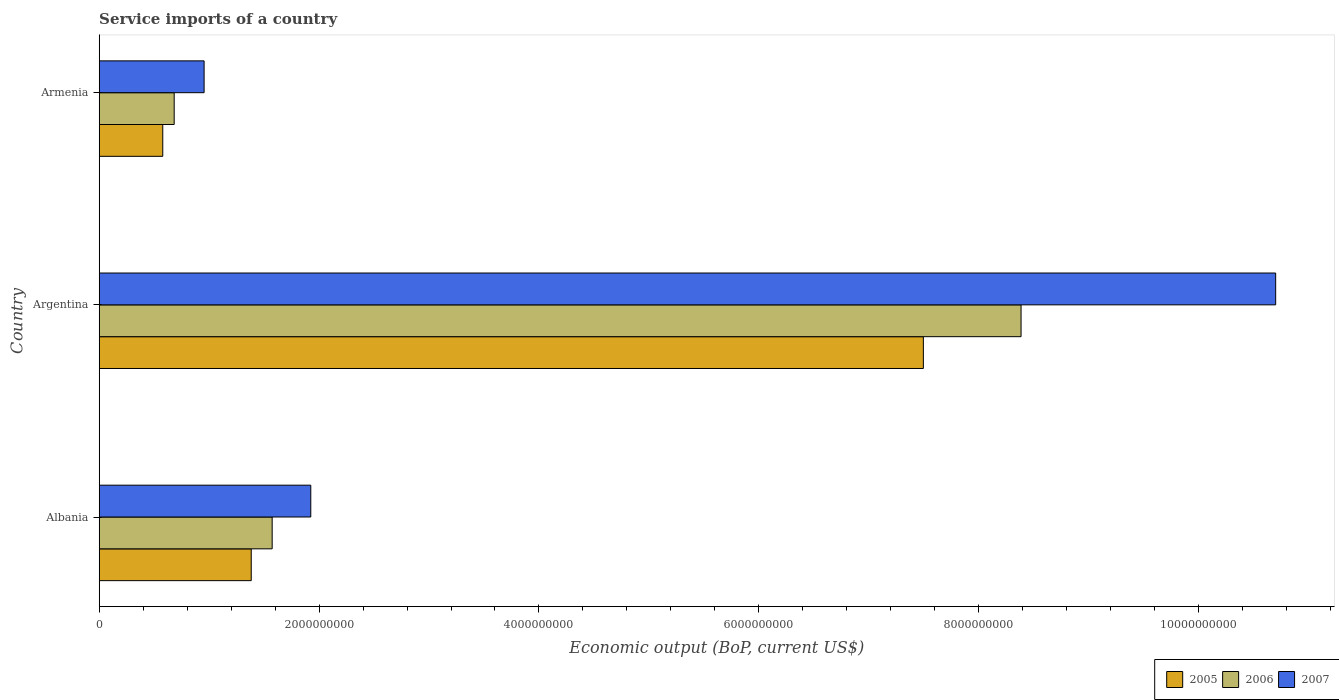How many different coloured bars are there?
Make the answer very short. 3. Are the number of bars on each tick of the Y-axis equal?
Provide a succinct answer. Yes. How many bars are there on the 2nd tick from the top?
Keep it short and to the point. 3. How many bars are there on the 1st tick from the bottom?
Ensure brevity in your answer.  3. What is the label of the 1st group of bars from the top?
Your response must be concise. Armenia. In how many cases, is the number of bars for a given country not equal to the number of legend labels?
Your answer should be compact. 0. What is the service imports in 2007 in Albania?
Offer a terse response. 1.92e+09. Across all countries, what is the maximum service imports in 2007?
Make the answer very short. 1.07e+1. Across all countries, what is the minimum service imports in 2007?
Offer a terse response. 9.54e+08. In which country was the service imports in 2006 maximum?
Give a very brief answer. Argentina. In which country was the service imports in 2005 minimum?
Offer a terse response. Armenia. What is the total service imports in 2005 in the graph?
Your response must be concise. 9.46e+09. What is the difference between the service imports in 2006 in Albania and that in Argentina?
Your response must be concise. -6.81e+09. What is the difference between the service imports in 2005 in Albania and the service imports in 2007 in Armenia?
Offer a very short reply. 4.29e+08. What is the average service imports in 2005 per country?
Give a very brief answer. 3.15e+09. What is the difference between the service imports in 2005 and service imports in 2007 in Albania?
Ensure brevity in your answer.  -5.42e+08. In how many countries, is the service imports in 2005 greater than 5200000000 US$?
Make the answer very short. 1. What is the ratio of the service imports in 2005 in Albania to that in Argentina?
Give a very brief answer. 0.18. Is the service imports in 2006 in Argentina less than that in Armenia?
Provide a short and direct response. No. What is the difference between the highest and the second highest service imports in 2007?
Offer a terse response. 8.78e+09. What is the difference between the highest and the lowest service imports in 2005?
Provide a succinct answer. 6.92e+09. Is the sum of the service imports in 2006 in Albania and Argentina greater than the maximum service imports in 2005 across all countries?
Ensure brevity in your answer.  Yes. Is it the case that in every country, the sum of the service imports in 2005 and service imports in 2006 is greater than the service imports in 2007?
Provide a succinct answer. Yes. How many bars are there?
Your response must be concise. 9. How many countries are there in the graph?
Provide a succinct answer. 3. Does the graph contain any zero values?
Keep it short and to the point. No. What is the title of the graph?
Keep it short and to the point. Service imports of a country. Does "1995" appear as one of the legend labels in the graph?
Offer a terse response. No. What is the label or title of the X-axis?
Make the answer very short. Economic output (BoP, current US$). What is the Economic output (BoP, current US$) in 2005 in Albania?
Offer a terse response. 1.38e+09. What is the Economic output (BoP, current US$) of 2006 in Albania?
Provide a succinct answer. 1.57e+09. What is the Economic output (BoP, current US$) of 2007 in Albania?
Offer a very short reply. 1.92e+09. What is the Economic output (BoP, current US$) of 2005 in Argentina?
Offer a terse response. 7.50e+09. What is the Economic output (BoP, current US$) of 2006 in Argentina?
Provide a short and direct response. 8.39e+09. What is the Economic output (BoP, current US$) in 2007 in Argentina?
Keep it short and to the point. 1.07e+1. What is the Economic output (BoP, current US$) in 2005 in Armenia?
Provide a short and direct response. 5.78e+08. What is the Economic output (BoP, current US$) of 2006 in Armenia?
Your answer should be compact. 6.82e+08. What is the Economic output (BoP, current US$) in 2007 in Armenia?
Provide a short and direct response. 9.54e+08. Across all countries, what is the maximum Economic output (BoP, current US$) in 2005?
Offer a terse response. 7.50e+09. Across all countries, what is the maximum Economic output (BoP, current US$) in 2006?
Offer a very short reply. 8.39e+09. Across all countries, what is the maximum Economic output (BoP, current US$) in 2007?
Your answer should be very brief. 1.07e+1. Across all countries, what is the minimum Economic output (BoP, current US$) of 2005?
Provide a succinct answer. 5.78e+08. Across all countries, what is the minimum Economic output (BoP, current US$) of 2006?
Make the answer very short. 6.82e+08. Across all countries, what is the minimum Economic output (BoP, current US$) in 2007?
Provide a succinct answer. 9.54e+08. What is the total Economic output (BoP, current US$) of 2005 in the graph?
Keep it short and to the point. 9.46e+09. What is the total Economic output (BoP, current US$) of 2006 in the graph?
Provide a succinct answer. 1.06e+1. What is the total Economic output (BoP, current US$) in 2007 in the graph?
Your answer should be very brief. 1.36e+1. What is the difference between the Economic output (BoP, current US$) of 2005 in Albania and that in Argentina?
Your answer should be compact. -6.11e+09. What is the difference between the Economic output (BoP, current US$) of 2006 in Albania and that in Argentina?
Your answer should be very brief. -6.81e+09. What is the difference between the Economic output (BoP, current US$) of 2007 in Albania and that in Argentina?
Your response must be concise. -8.78e+09. What is the difference between the Economic output (BoP, current US$) of 2005 in Albania and that in Armenia?
Your answer should be very brief. 8.05e+08. What is the difference between the Economic output (BoP, current US$) of 2006 in Albania and that in Armenia?
Give a very brief answer. 8.91e+08. What is the difference between the Economic output (BoP, current US$) in 2007 in Albania and that in Armenia?
Provide a short and direct response. 9.70e+08. What is the difference between the Economic output (BoP, current US$) in 2005 in Argentina and that in Armenia?
Give a very brief answer. 6.92e+09. What is the difference between the Economic output (BoP, current US$) of 2006 in Argentina and that in Armenia?
Provide a succinct answer. 7.70e+09. What is the difference between the Economic output (BoP, current US$) of 2007 in Argentina and that in Armenia?
Make the answer very short. 9.75e+09. What is the difference between the Economic output (BoP, current US$) in 2005 in Albania and the Economic output (BoP, current US$) in 2006 in Argentina?
Your answer should be very brief. -7.00e+09. What is the difference between the Economic output (BoP, current US$) in 2005 in Albania and the Economic output (BoP, current US$) in 2007 in Argentina?
Make the answer very short. -9.32e+09. What is the difference between the Economic output (BoP, current US$) in 2006 in Albania and the Economic output (BoP, current US$) in 2007 in Argentina?
Provide a succinct answer. -9.13e+09. What is the difference between the Economic output (BoP, current US$) in 2005 in Albania and the Economic output (BoP, current US$) in 2006 in Armenia?
Provide a succinct answer. 7.01e+08. What is the difference between the Economic output (BoP, current US$) of 2005 in Albania and the Economic output (BoP, current US$) of 2007 in Armenia?
Provide a succinct answer. 4.29e+08. What is the difference between the Economic output (BoP, current US$) of 2006 in Albania and the Economic output (BoP, current US$) of 2007 in Armenia?
Your answer should be very brief. 6.19e+08. What is the difference between the Economic output (BoP, current US$) of 2005 in Argentina and the Economic output (BoP, current US$) of 2006 in Armenia?
Your response must be concise. 6.81e+09. What is the difference between the Economic output (BoP, current US$) in 2005 in Argentina and the Economic output (BoP, current US$) in 2007 in Armenia?
Provide a succinct answer. 6.54e+09. What is the difference between the Economic output (BoP, current US$) of 2006 in Argentina and the Economic output (BoP, current US$) of 2007 in Armenia?
Make the answer very short. 7.43e+09. What is the average Economic output (BoP, current US$) of 2005 per country?
Provide a short and direct response. 3.15e+09. What is the average Economic output (BoP, current US$) of 2006 per country?
Offer a very short reply. 3.55e+09. What is the average Economic output (BoP, current US$) in 2007 per country?
Provide a short and direct response. 4.53e+09. What is the difference between the Economic output (BoP, current US$) of 2005 and Economic output (BoP, current US$) of 2006 in Albania?
Keep it short and to the point. -1.90e+08. What is the difference between the Economic output (BoP, current US$) in 2005 and Economic output (BoP, current US$) in 2007 in Albania?
Ensure brevity in your answer.  -5.42e+08. What is the difference between the Economic output (BoP, current US$) of 2006 and Economic output (BoP, current US$) of 2007 in Albania?
Provide a short and direct response. -3.51e+08. What is the difference between the Economic output (BoP, current US$) of 2005 and Economic output (BoP, current US$) of 2006 in Argentina?
Ensure brevity in your answer.  -8.89e+08. What is the difference between the Economic output (BoP, current US$) in 2005 and Economic output (BoP, current US$) in 2007 in Argentina?
Offer a terse response. -3.20e+09. What is the difference between the Economic output (BoP, current US$) of 2006 and Economic output (BoP, current US$) of 2007 in Argentina?
Give a very brief answer. -2.32e+09. What is the difference between the Economic output (BoP, current US$) in 2005 and Economic output (BoP, current US$) in 2006 in Armenia?
Your response must be concise. -1.04e+08. What is the difference between the Economic output (BoP, current US$) in 2005 and Economic output (BoP, current US$) in 2007 in Armenia?
Provide a short and direct response. -3.76e+08. What is the difference between the Economic output (BoP, current US$) of 2006 and Economic output (BoP, current US$) of 2007 in Armenia?
Your response must be concise. -2.72e+08. What is the ratio of the Economic output (BoP, current US$) in 2005 in Albania to that in Argentina?
Your response must be concise. 0.18. What is the ratio of the Economic output (BoP, current US$) in 2006 in Albania to that in Argentina?
Your answer should be compact. 0.19. What is the ratio of the Economic output (BoP, current US$) of 2007 in Albania to that in Argentina?
Keep it short and to the point. 0.18. What is the ratio of the Economic output (BoP, current US$) of 2005 in Albania to that in Armenia?
Keep it short and to the point. 2.39. What is the ratio of the Economic output (BoP, current US$) of 2006 in Albania to that in Armenia?
Provide a succinct answer. 2.31. What is the ratio of the Economic output (BoP, current US$) in 2007 in Albania to that in Armenia?
Your response must be concise. 2.02. What is the ratio of the Economic output (BoP, current US$) of 2005 in Argentina to that in Armenia?
Make the answer very short. 12.97. What is the ratio of the Economic output (BoP, current US$) in 2006 in Argentina to that in Armenia?
Make the answer very short. 12.3. What is the ratio of the Economic output (BoP, current US$) of 2007 in Argentina to that in Armenia?
Ensure brevity in your answer.  11.22. What is the difference between the highest and the second highest Economic output (BoP, current US$) in 2005?
Make the answer very short. 6.11e+09. What is the difference between the highest and the second highest Economic output (BoP, current US$) of 2006?
Keep it short and to the point. 6.81e+09. What is the difference between the highest and the second highest Economic output (BoP, current US$) in 2007?
Offer a very short reply. 8.78e+09. What is the difference between the highest and the lowest Economic output (BoP, current US$) of 2005?
Give a very brief answer. 6.92e+09. What is the difference between the highest and the lowest Economic output (BoP, current US$) in 2006?
Provide a short and direct response. 7.70e+09. What is the difference between the highest and the lowest Economic output (BoP, current US$) of 2007?
Provide a short and direct response. 9.75e+09. 